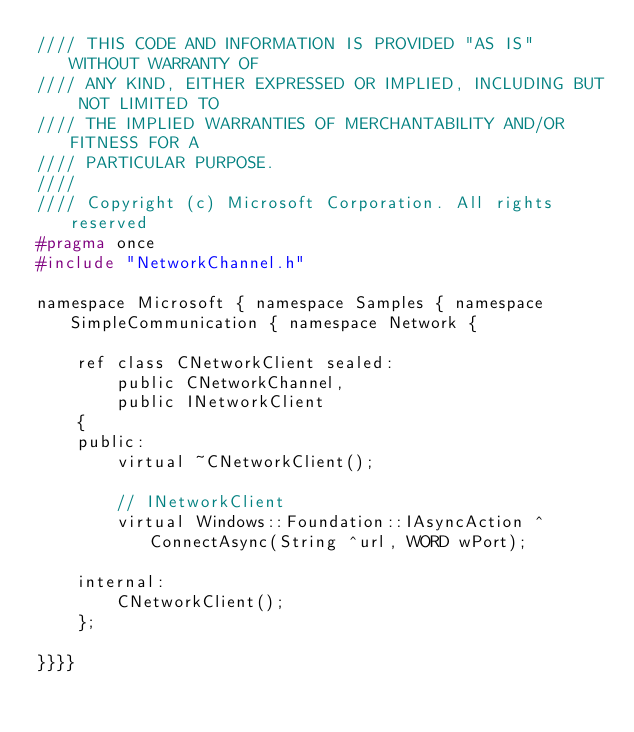Convert code to text. <code><loc_0><loc_0><loc_500><loc_500><_C_>//// THIS CODE AND INFORMATION IS PROVIDED "AS IS" WITHOUT WARRANTY OF
//// ANY KIND, EITHER EXPRESSED OR IMPLIED, INCLUDING BUT NOT LIMITED TO
//// THE IMPLIED WARRANTIES OF MERCHANTABILITY AND/OR FITNESS FOR A
//// PARTICULAR PURPOSE.
////
//// Copyright (c) Microsoft Corporation. All rights reserved
#pragma once
#include "NetworkChannel.h"

namespace Microsoft { namespace Samples { namespace SimpleCommunication { namespace Network {

    ref class CNetworkClient sealed: 
        public CNetworkChannel, 
        public INetworkClient
    {
    public:
        virtual ~CNetworkClient();

        // INetworkClient
        virtual Windows::Foundation::IAsyncAction ^ConnectAsync(String ^url, WORD wPort);

    internal:
        CNetworkClient();
    };

}}}}</code> 